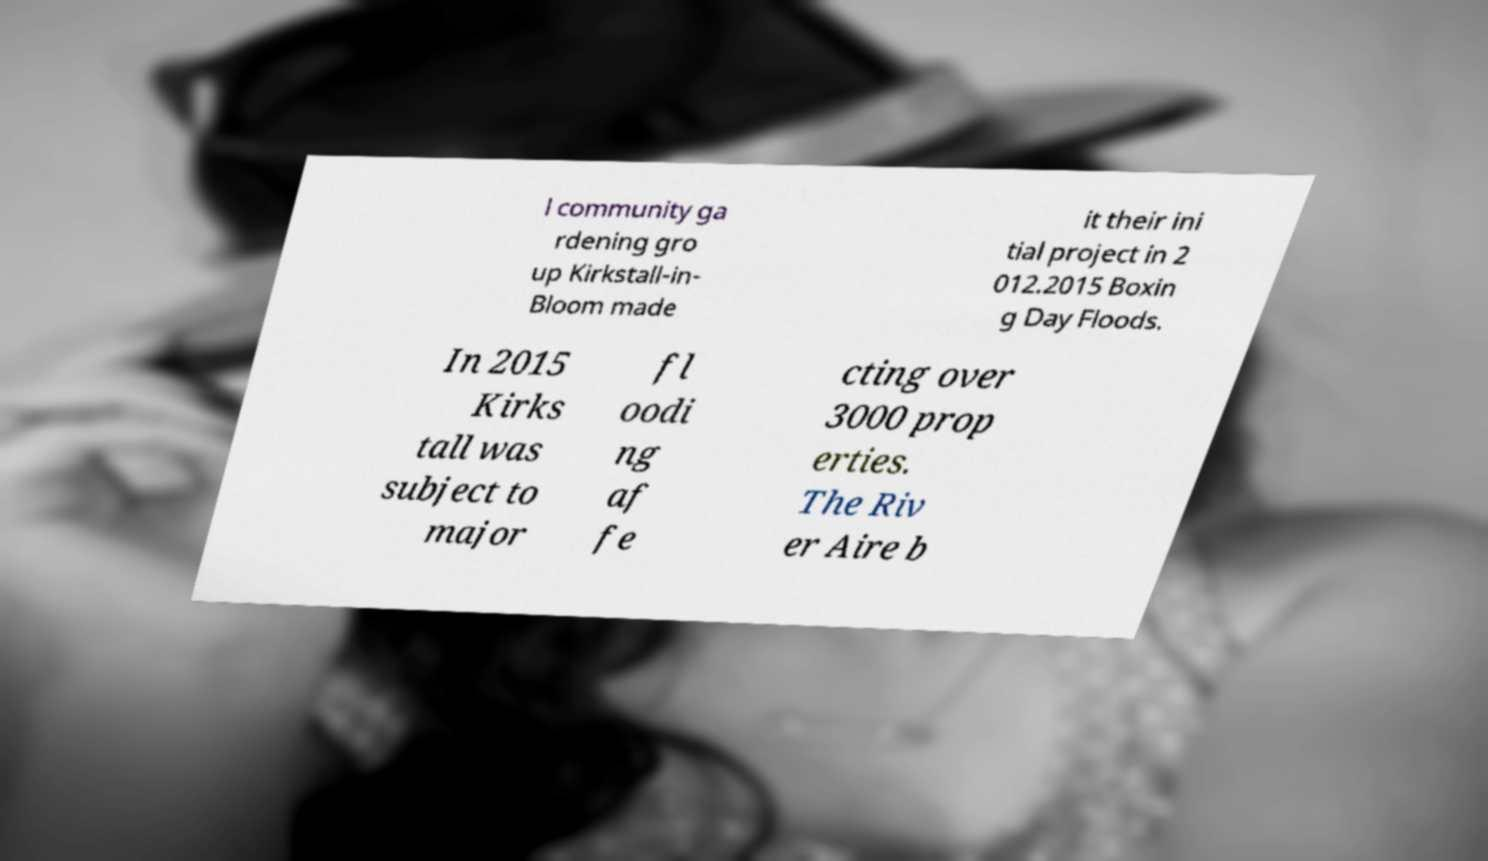There's text embedded in this image that I need extracted. Can you transcribe it verbatim? l community ga rdening gro up Kirkstall-in- Bloom made it their ini tial project in 2 012.2015 Boxin g Day Floods. In 2015 Kirks tall was subject to major fl oodi ng af fe cting over 3000 prop erties. The Riv er Aire b 